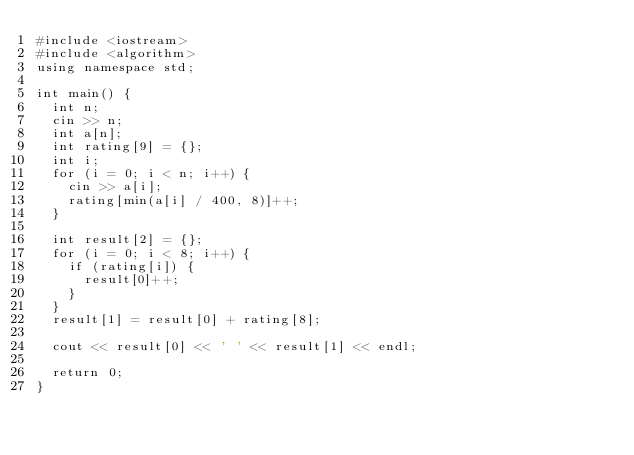Convert code to text. <code><loc_0><loc_0><loc_500><loc_500><_C++_>#include <iostream>
#include <algorithm>
using namespace std;

int main() {
  int n;
  cin >> n;
  int a[n];
  int rating[9] = {};
  int i;
  for (i = 0; i < n; i++) {
    cin >> a[i];
    rating[min(a[i] / 400, 8)]++;
  }

  int result[2] = {};
  for (i = 0; i < 8; i++) {
    if (rating[i]) {
      result[0]++;
    }
  }
  result[1] = result[0] + rating[8];

  cout << result[0] << ' ' << result[1] << endl;

  return 0;
}
</code> 